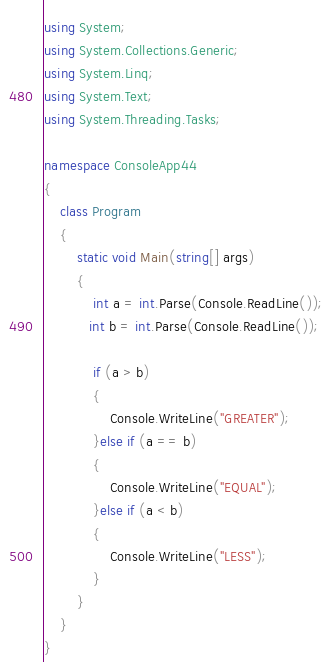Convert code to text. <code><loc_0><loc_0><loc_500><loc_500><_C#_>using System;
using System.Collections.Generic;
using System.Linq;
using System.Text;
using System.Threading.Tasks;

namespace ConsoleApp44
{
    class Program
    {
        static void Main(string[] args)
        {
            int a = int.Parse(Console.ReadLine());
           int b = int.Parse(Console.ReadLine());

            if (a > b)
            {
                Console.WriteLine("GREATER");
            }else if (a == b)
            {
                Console.WriteLine("EQUAL");
            }else if (a < b)
            {
                Console.WriteLine("LESS");
            }
        }
    }
}
</code> 